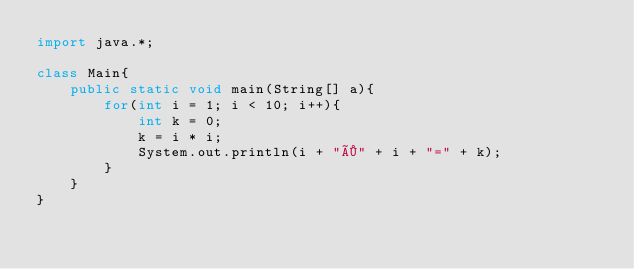Convert code to text. <code><loc_0><loc_0><loc_500><loc_500><_Java_>import java.*;

class Main{
    public static void main(String[] a){
		for(int i = 1; i < 10; i++){
			int k = 0;
			k = i * i;
			System.out.println(i + "×" + i + "=" + k);
		}
    }
}</code> 